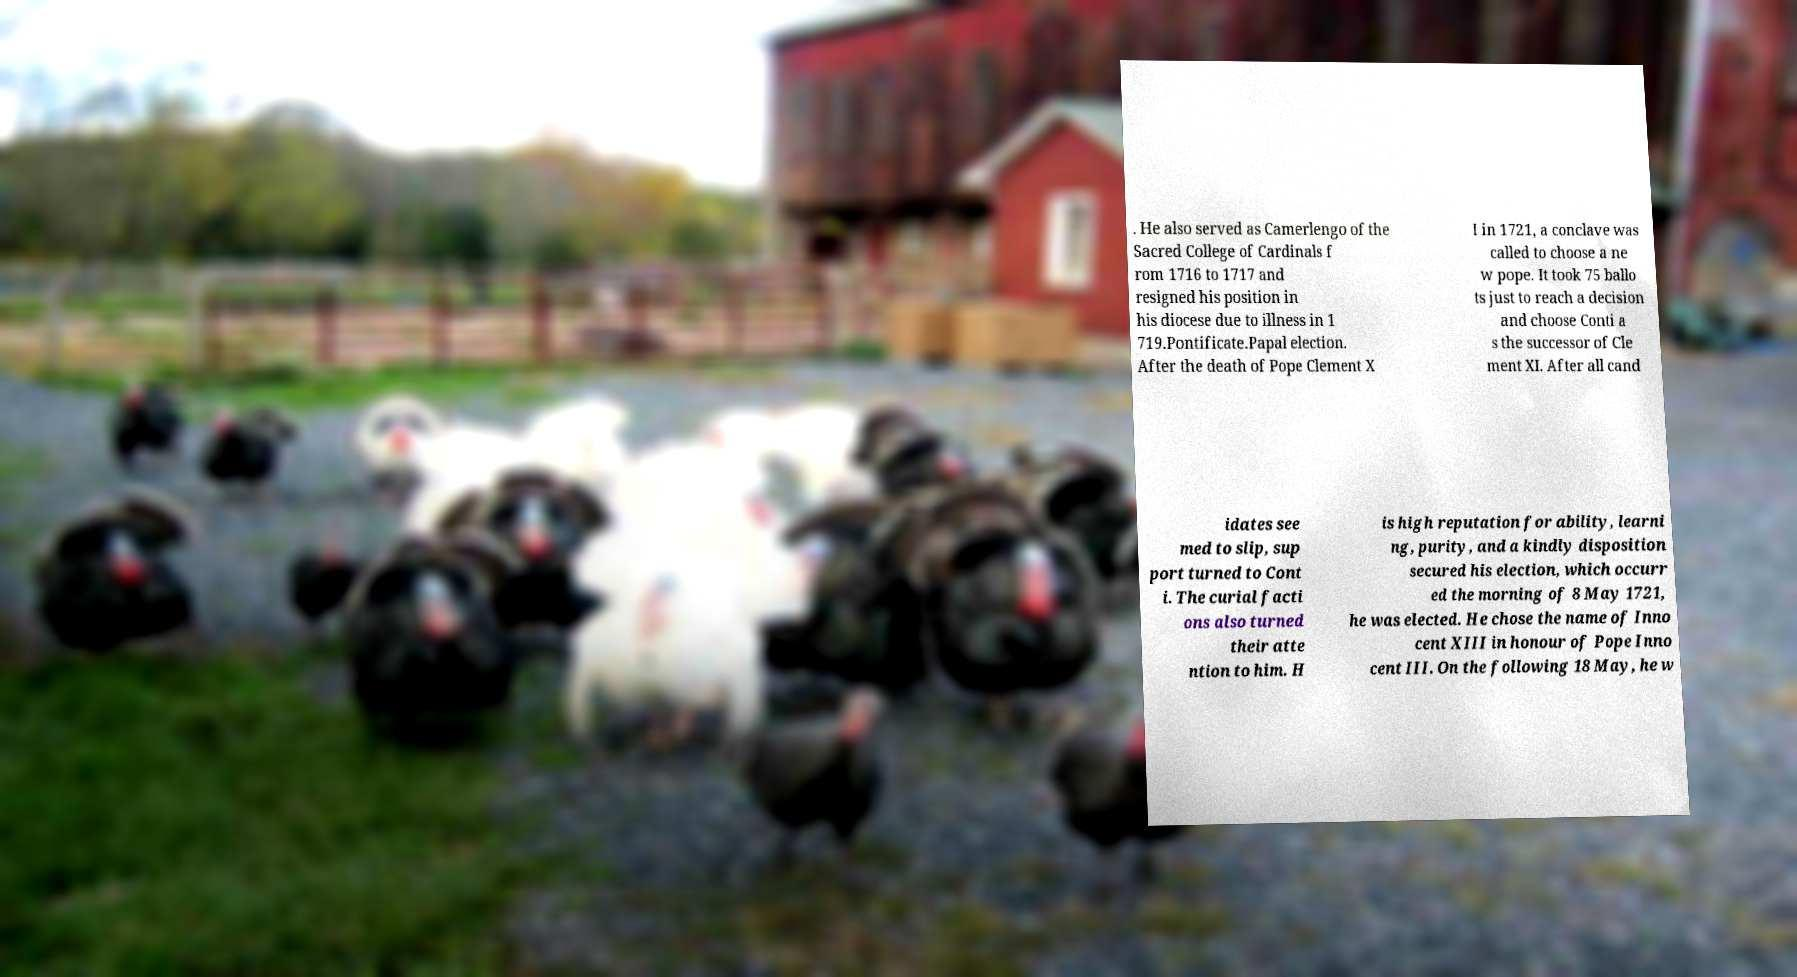Could you extract and type out the text from this image? . He also served as Camerlengo of the Sacred College of Cardinals f rom 1716 to 1717 and resigned his position in his diocese due to illness in 1 719.Pontificate.Papal election. After the death of Pope Clement X I in 1721, a conclave was called to choose a ne w pope. It took 75 ballo ts just to reach a decision and choose Conti a s the successor of Cle ment XI. After all cand idates see med to slip, sup port turned to Cont i. The curial facti ons also turned their atte ntion to him. H is high reputation for ability, learni ng, purity, and a kindly disposition secured his election, which occurr ed the morning of 8 May 1721, he was elected. He chose the name of Inno cent XIII in honour of Pope Inno cent III. On the following 18 May, he w 